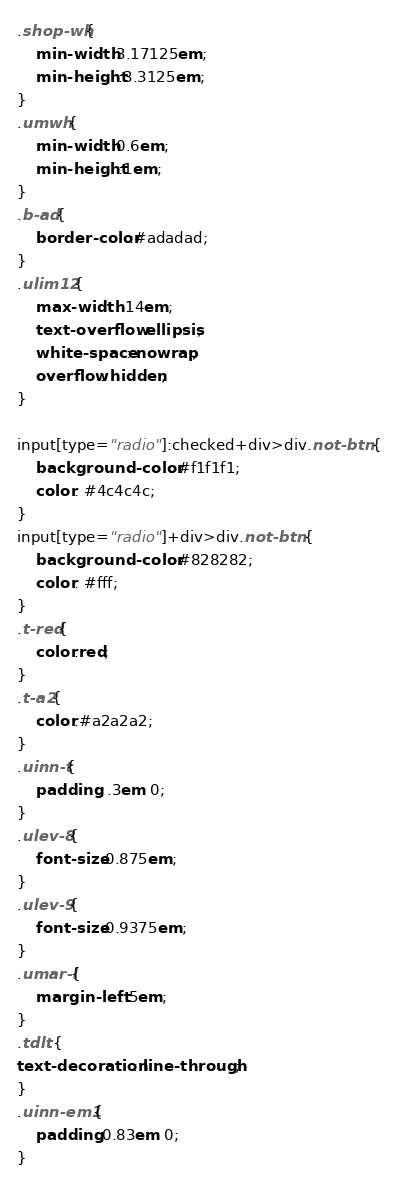Convert code to text. <code><loc_0><loc_0><loc_500><loc_500><_CSS_>.shop-wh{
	min-width:3.17125em;
	min-height:3.3125em;
}
.umwh{
	min-width:0.6em;
	min-height:1em;
}
.b-ad{
	border-color:#adadad;
}
.ulim12{
	max-width: 14em;
	text-overflow: ellipsis;
	white-space: nowrap;
	overflow: hidden;
}

input[type="radio"]:checked+div>div.not-btn {
	background-color: #f1f1f1;
	color: #4c4c4c;
}
input[type="radio"]+div>div.not-btn {
	background-color: #828282;
	color: #fff;
}
.t-red{
	color:red;
}
.t-a2{
	color:#a2a2a2;
}
.uinn-t{
	padding: .3em 0;
}
.ulev-8{
	font-size:0.875em;
}
.ulev-9{
	font-size:0.9375em;
}
.umar-l{
	margin-left:.5em;
}
.tdlt {
text-decoration: line-through;
}
.uinn-em1{
	padding:0.83em 0;
}
</code> 